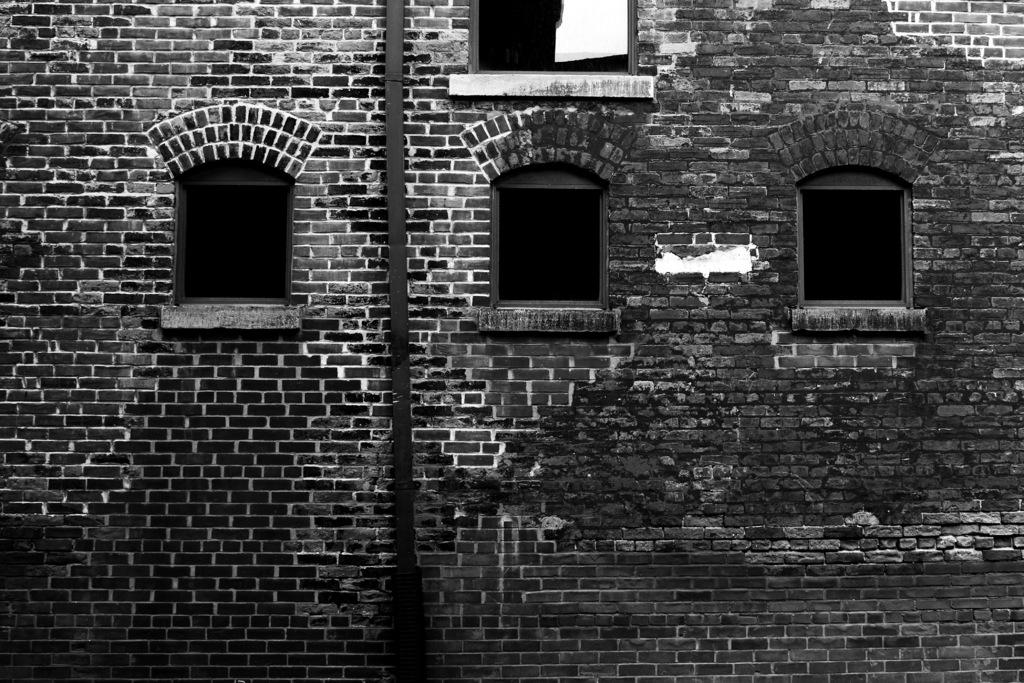What type of image is shown in the photograph? The image is a black and white photograph. What is the main subject of the photograph? The photograph depicts a brick wall. Are there any openings in the brick wall? Yes, the brick wall has windows. What type of jeans can be seen hanging on the wall in the image? There are no jeans present in the image; it features a black and white photograph of a brick wall with windows. What type of cannon is visible in the image? There is no cannon present in the image; it features a brick wall with windows in a black and white photograph. 